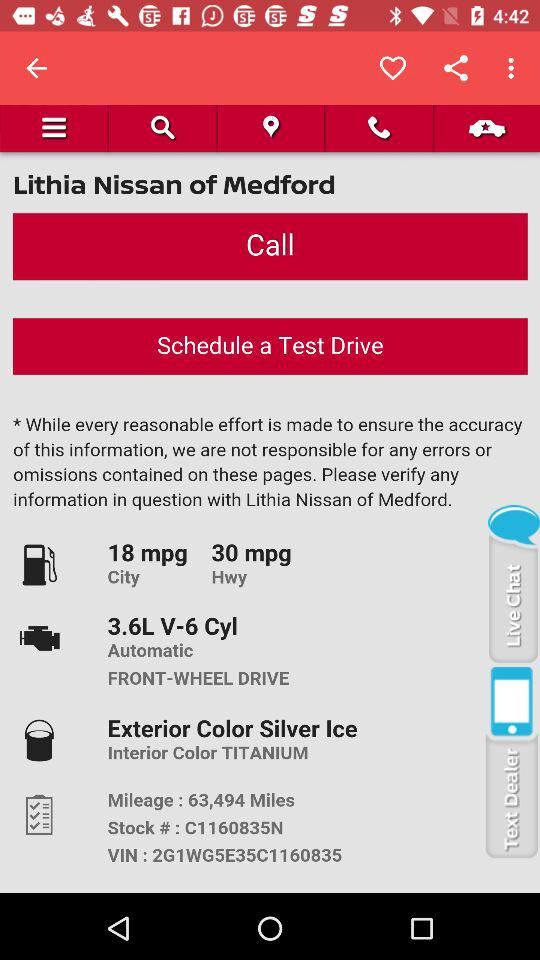How much mpg does it give in the city? It gives 18 mpg. 